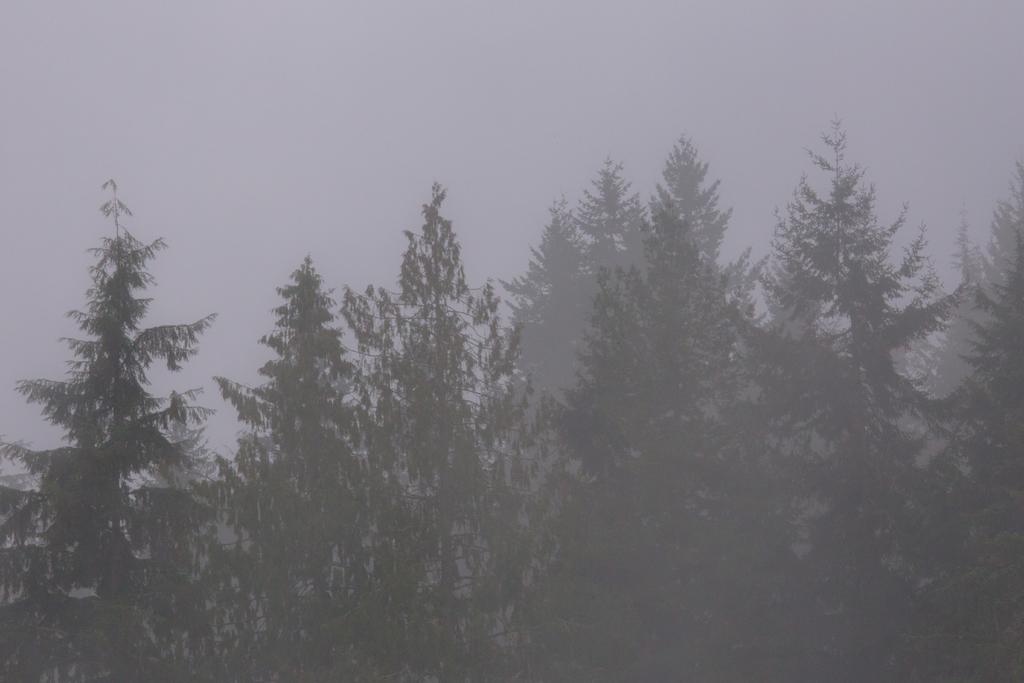What type of vegetation can be seen in the image? There are trees in the image. What can be seen in the sky in the image? There are clouds in the sky. Can you see any fairies flying among the trees in the image? There are no fairies present in the image; it only features trees and clouds. Is there a brother in the image? There is no mention of a brother or any people in the image; it only includes trees and clouds. 